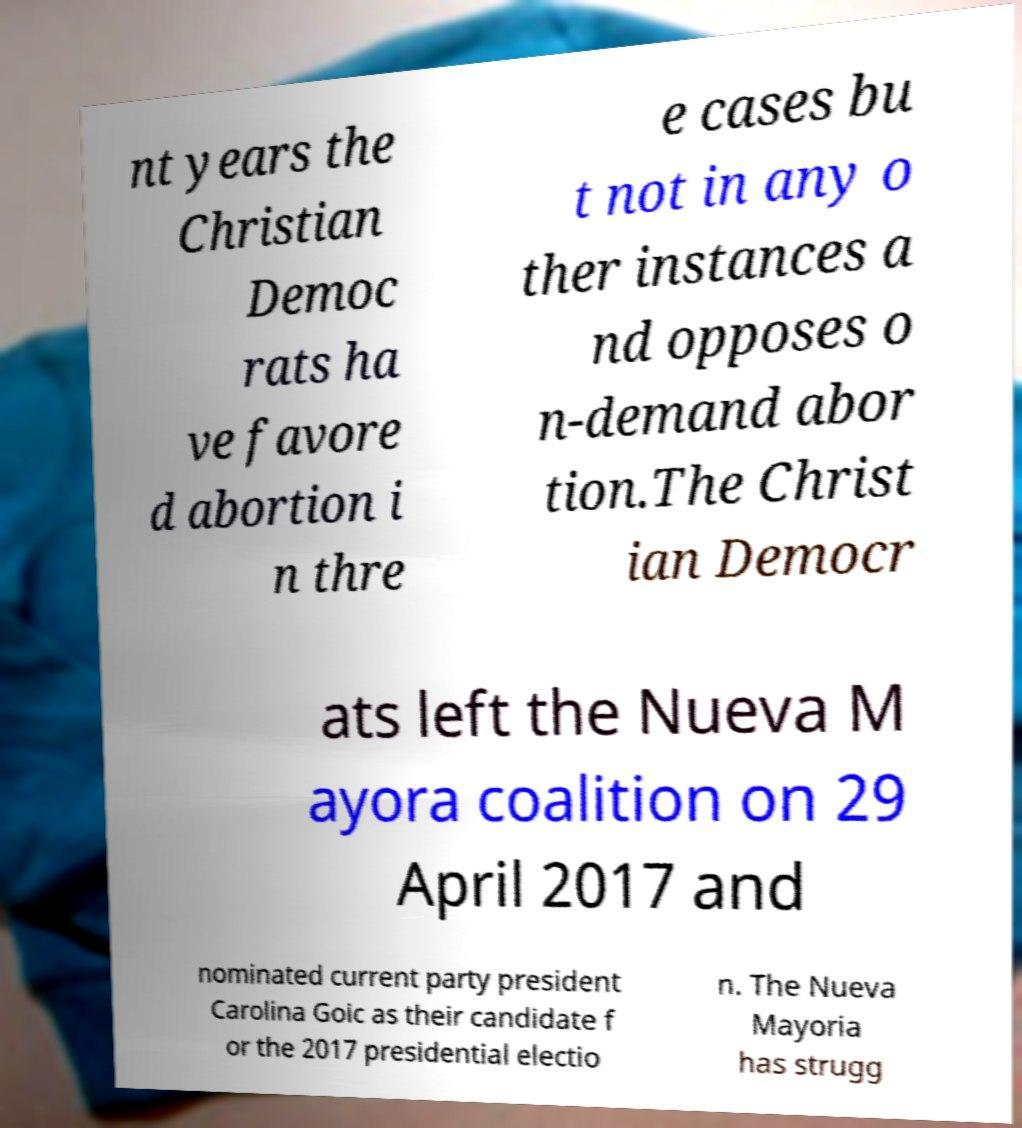Could you extract and type out the text from this image? nt years the Christian Democ rats ha ve favore d abortion i n thre e cases bu t not in any o ther instances a nd opposes o n-demand abor tion.The Christ ian Democr ats left the Nueva M ayora coalition on 29 April 2017 and nominated current party president Carolina Goic as their candidate f or the 2017 presidential electio n. The Nueva Mayoria has strugg 